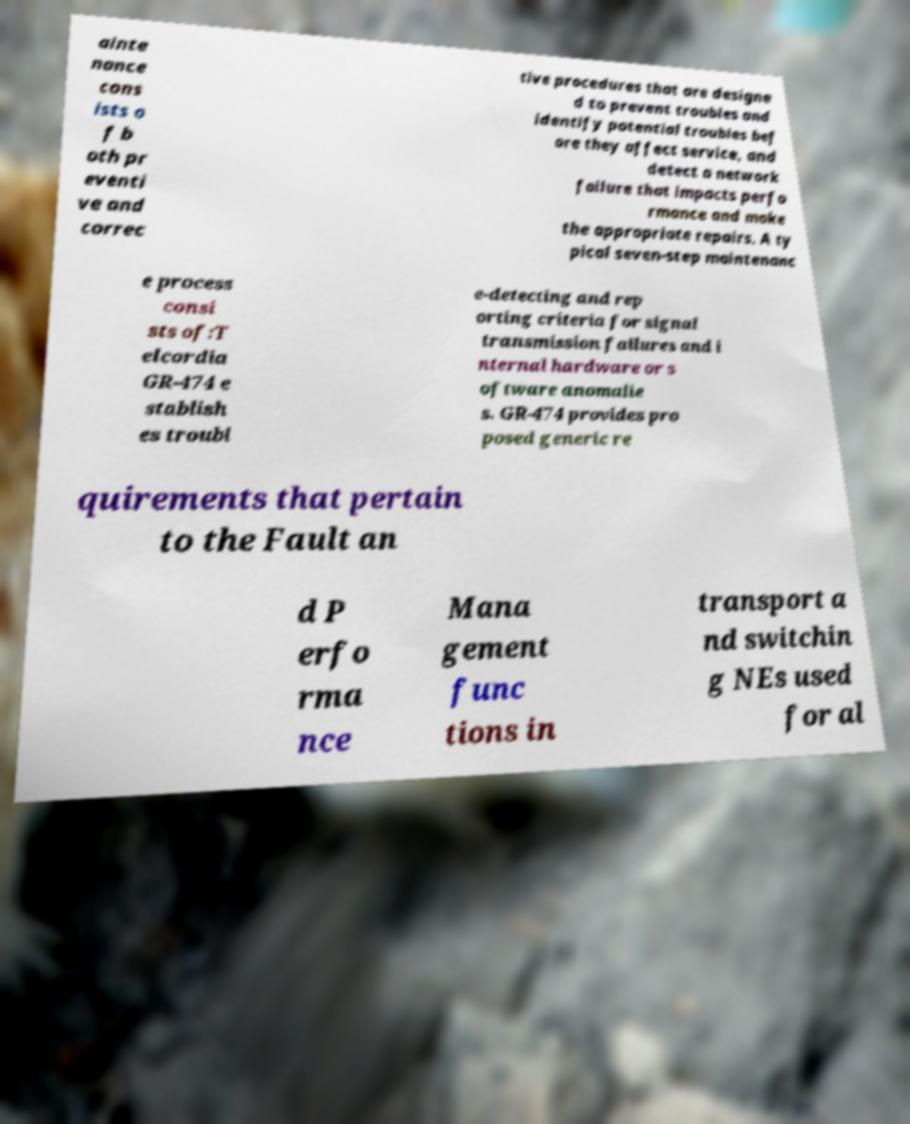For documentation purposes, I need the text within this image transcribed. Could you provide that? ainte nance cons ists o f b oth pr eventi ve and correc tive procedures that are designe d to prevent troubles and identify potential troubles bef ore they affect service, and detect a network failure that impacts perfo rmance and make the appropriate repairs. A ty pical seven-step maintenanc e process consi sts of:T elcordia GR-474 e stablish es troubl e-detecting and rep orting criteria for signal transmission failures and i nternal hardware or s oftware anomalie s. GR-474 provides pro posed generic re quirements that pertain to the Fault an d P erfo rma nce Mana gement func tions in transport a nd switchin g NEs used for al 